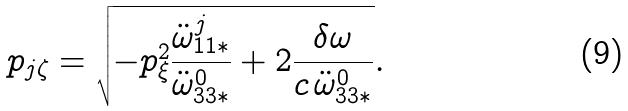Convert formula to latex. <formula><loc_0><loc_0><loc_500><loc_500>p _ { j \zeta } = \sqrt { - p _ { \xi } ^ { 2 } \frac { \ddot { \omega } ^ { j } _ { 1 1 * } } { \ddot { \omega } ^ { 0 } _ { 3 3 * } } + 2 \frac { \delta \omega } { c \, \ddot { \omega } ^ { 0 } _ { 3 3 * } } } .</formula> 